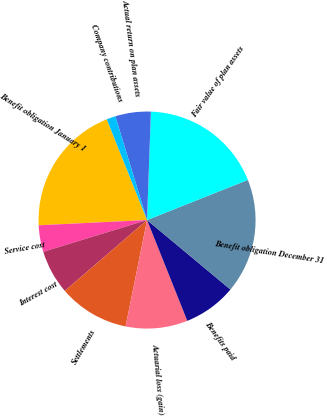<chart> <loc_0><loc_0><loc_500><loc_500><pie_chart><fcel>Benefit obligation January 1<fcel>Service cost<fcel>Interest cost<fcel>Settlements<fcel>Actuarial loss (gain)<fcel>Benefits paid<fcel>Benefit obligation December 31<fcel>Fair value of plan assets<fcel>Actual return on plan assets<fcel>Company contributions<nl><fcel>19.71%<fcel>3.96%<fcel>6.59%<fcel>10.52%<fcel>9.21%<fcel>7.9%<fcel>17.09%<fcel>18.4%<fcel>5.28%<fcel>1.34%<nl></chart> 